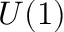<formula> <loc_0><loc_0><loc_500><loc_500>U ( 1 )</formula> 